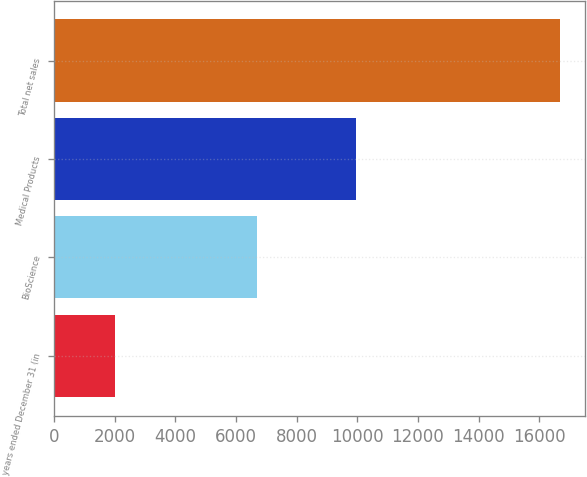<chart> <loc_0><loc_0><loc_500><loc_500><bar_chart><fcel>years ended December 31 (in<fcel>BioScience<fcel>Medical Products<fcel>Total net sales<nl><fcel>2014<fcel>6699<fcel>9972<fcel>16671<nl></chart> 